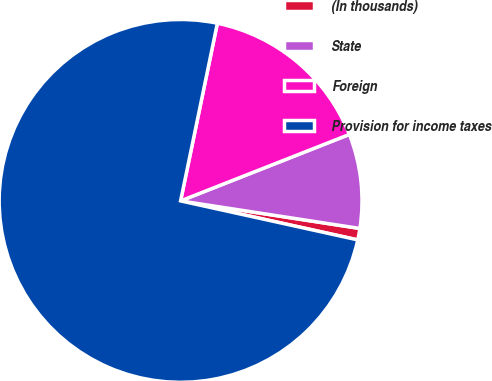Convert chart to OTSL. <chart><loc_0><loc_0><loc_500><loc_500><pie_chart><fcel>(In thousands)<fcel>State<fcel>Foreign<fcel>Provision for income taxes<nl><fcel>1.02%<fcel>8.4%<fcel>15.78%<fcel>74.8%<nl></chart> 